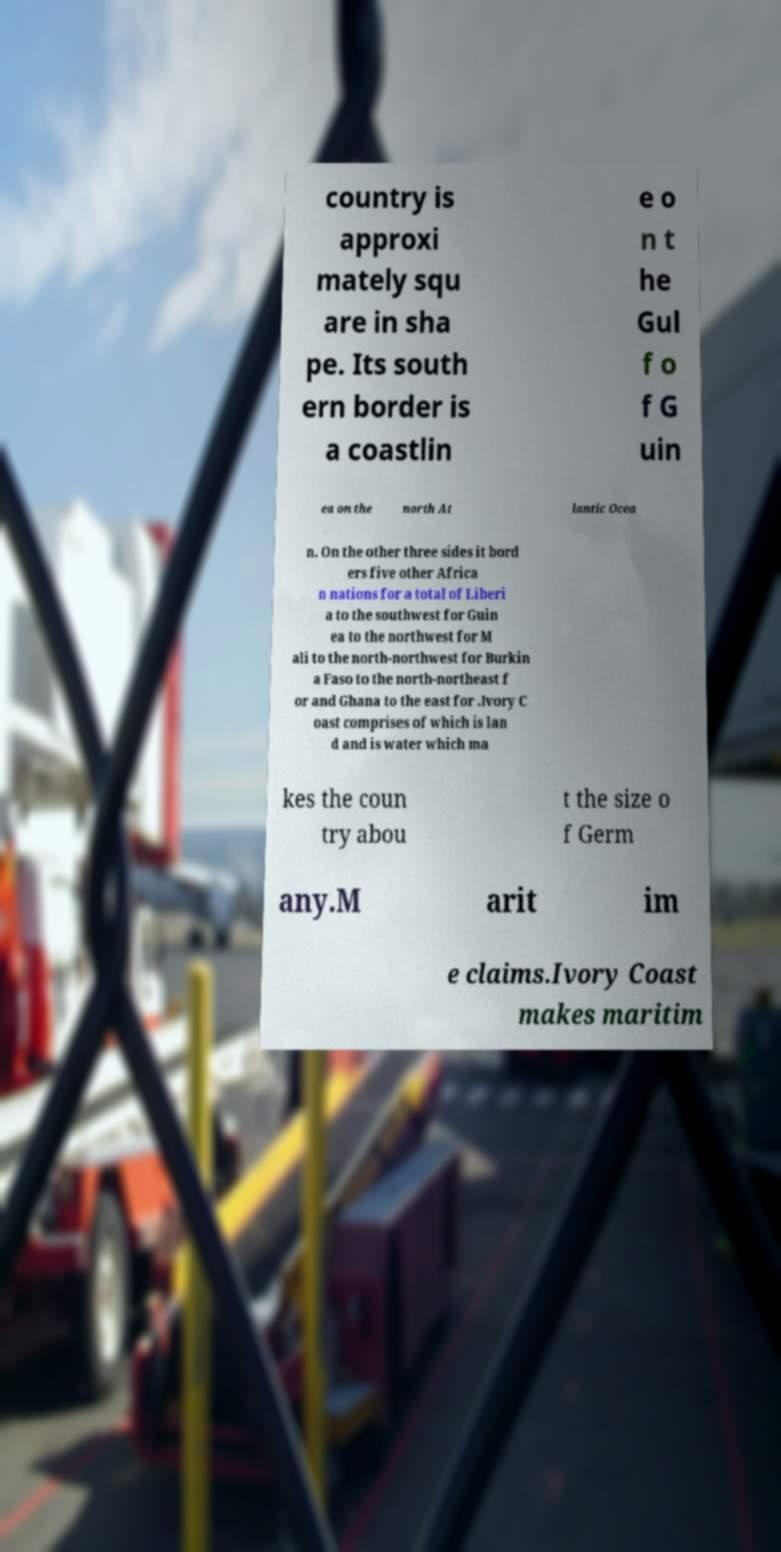Can you accurately transcribe the text from the provided image for me? country is approxi mately squ are in sha pe. Its south ern border is a coastlin e o n t he Gul f o f G uin ea on the north At lantic Ocea n. On the other three sides it bord ers five other Africa n nations for a total of Liberi a to the southwest for Guin ea to the northwest for M ali to the north-northwest for Burkin a Faso to the north-northeast f or and Ghana to the east for .Ivory C oast comprises of which is lan d and is water which ma kes the coun try abou t the size o f Germ any.M arit im e claims.Ivory Coast makes maritim 